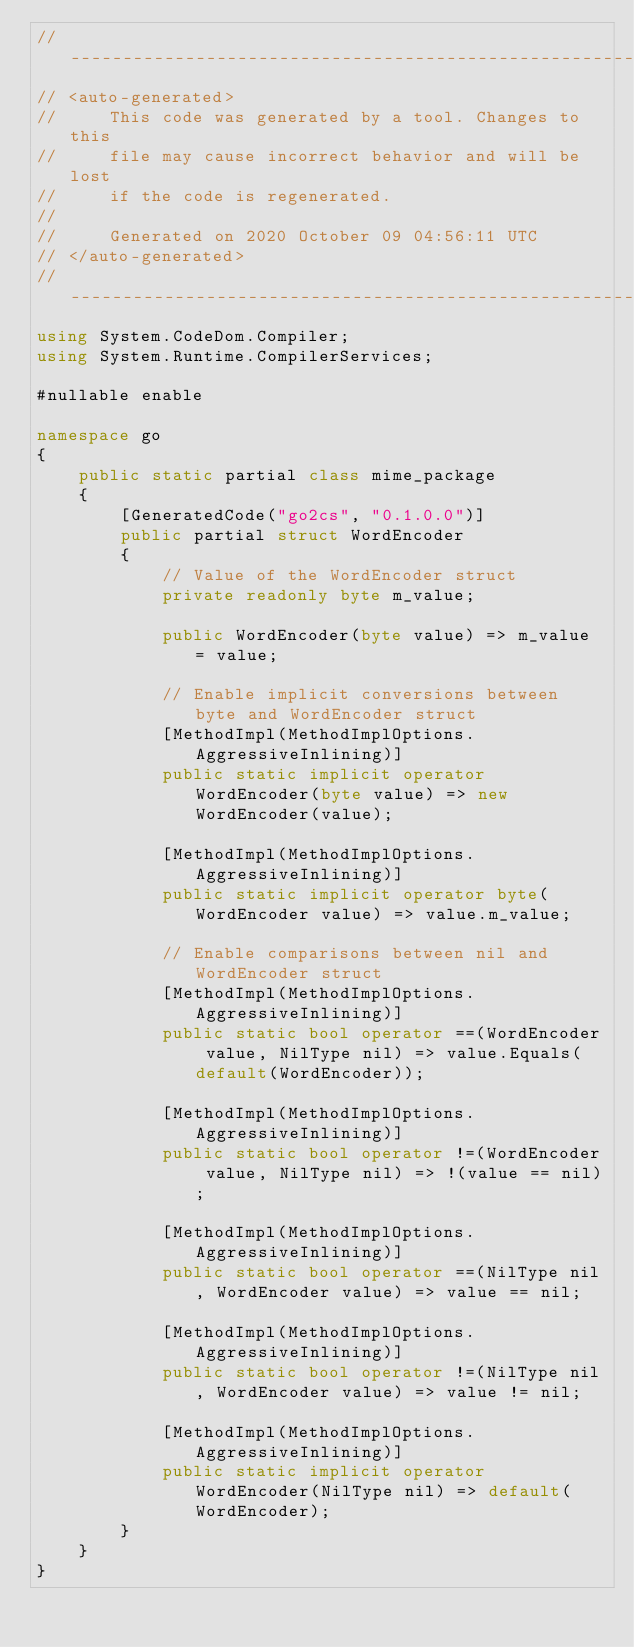Convert code to text. <code><loc_0><loc_0><loc_500><loc_500><_C#_>//---------------------------------------------------------
// <auto-generated>
//     This code was generated by a tool. Changes to this
//     file may cause incorrect behavior and will be lost
//     if the code is regenerated.
//
//     Generated on 2020 October 09 04:56:11 UTC
// </auto-generated>
//---------------------------------------------------------
using System.CodeDom.Compiler;
using System.Runtime.CompilerServices;

#nullable enable

namespace go
{
    public static partial class mime_package
    {
        [GeneratedCode("go2cs", "0.1.0.0")]
        public partial struct WordEncoder
        {
            // Value of the WordEncoder struct
            private readonly byte m_value;

            public WordEncoder(byte value) => m_value = value;

            // Enable implicit conversions between byte and WordEncoder struct
            [MethodImpl(MethodImplOptions.AggressiveInlining)]
            public static implicit operator WordEncoder(byte value) => new WordEncoder(value);
            
            [MethodImpl(MethodImplOptions.AggressiveInlining)]
            public static implicit operator byte(WordEncoder value) => value.m_value;
            
            // Enable comparisons between nil and WordEncoder struct
            [MethodImpl(MethodImplOptions.AggressiveInlining)]
            public static bool operator ==(WordEncoder value, NilType nil) => value.Equals(default(WordEncoder));

            [MethodImpl(MethodImplOptions.AggressiveInlining)]
            public static bool operator !=(WordEncoder value, NilType nil) => !(value == nil);

            [MethodImpl(MethodImplOptions.AggressiveInlining)]
            public static bool operator ==(NilType nil, WordEncoder value) => value == nil;

            [MethodImpl(MethodImplOptions.AggressiveInlining)]
            public static bool operator !=(NilType nil, WordEncoder value) => value != nil;

            [MethodImpl(MethodImplOptions.AggressiveInlining)]
            public static implicit operator WordEncoder(NilType nil) => default(WordEncoder);
        }
    }
}
</code> 